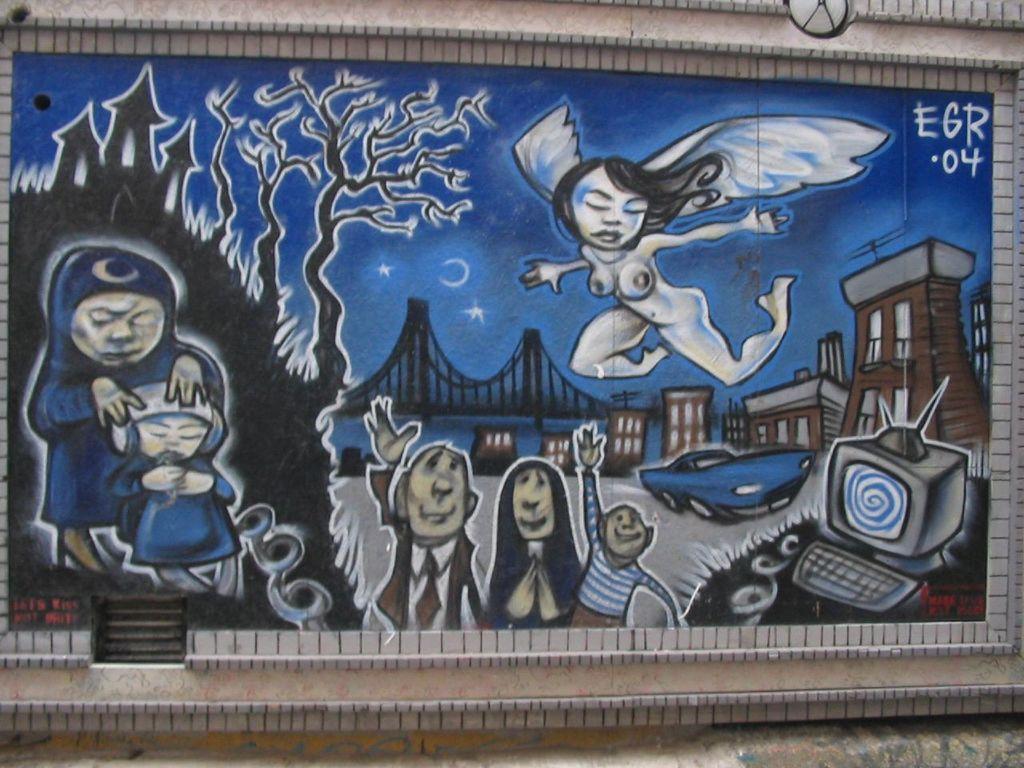In one or two sentences, can you explain what this image depicts? In this image I can see a frame which consists of painting and it is attached to a wall. In the frame, I can see the depictions of few persons, buildings, trees and a car. 